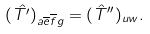Convert formula to latex. <formula><loc_0><loc_0><loc_500><loc_500>( \hat { T ^ { \prime } } ) _ { a \overline { e } \overline { f } g } = ( \hat { T } ^ { \prime \prime } ) _ { u w } .</formula> 